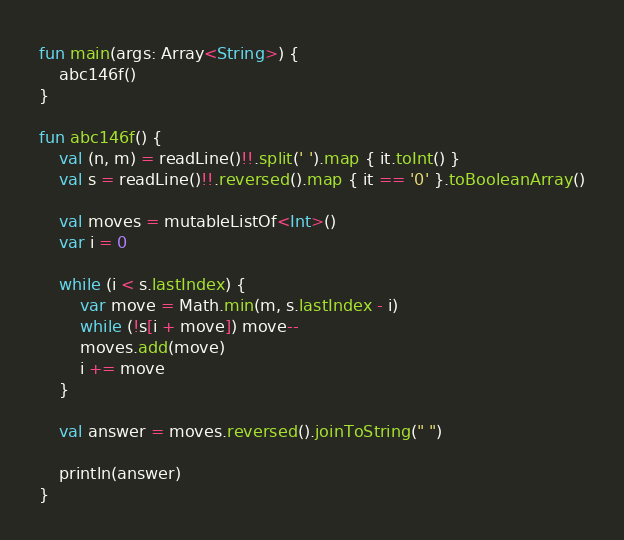Convert code to text. <code><loc_0><loc_0><loc_500><loc_500><_Kotlin_>fun main(args: Array<String>) {
    abc146f()
}

fun abc146f() {
    val (n, m) = readLine()!!.split(' ').map { it.toInt() }
    val s = readLine()!!.reversed().map { it == '0' }.toBooleanArray()

    val moves = mutableListOf<Int>()
    var i = 0

    while (i < s.lastIndex) {
        var move = Math.min(m, s.lastIndex - i)
        while (!s[i + move]) move--
        moves.add(move)
        i += move
    }

    val answer = moves.reversed().joinToString(" ")

    println(answer)
}
</code> 